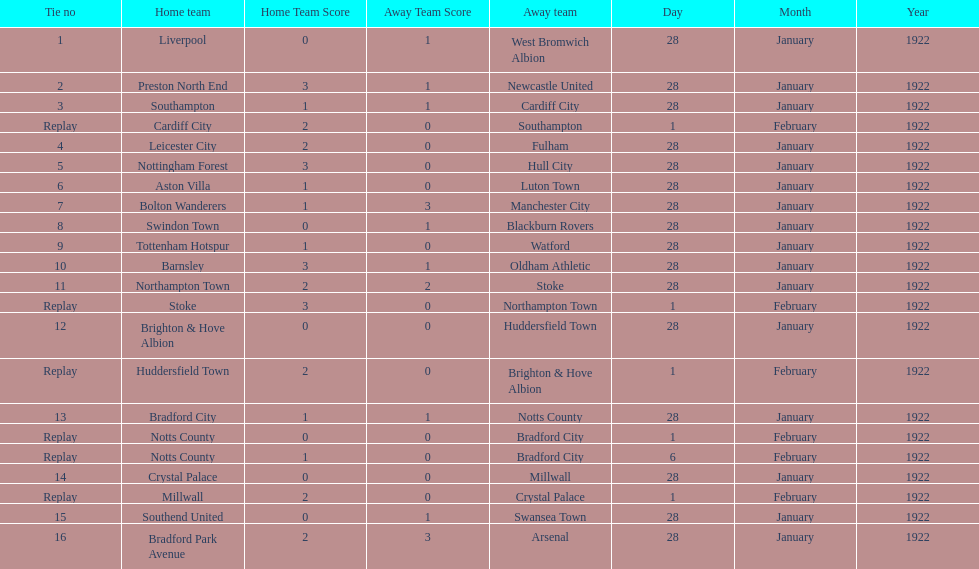How many games had four total points scored or more? 5. 